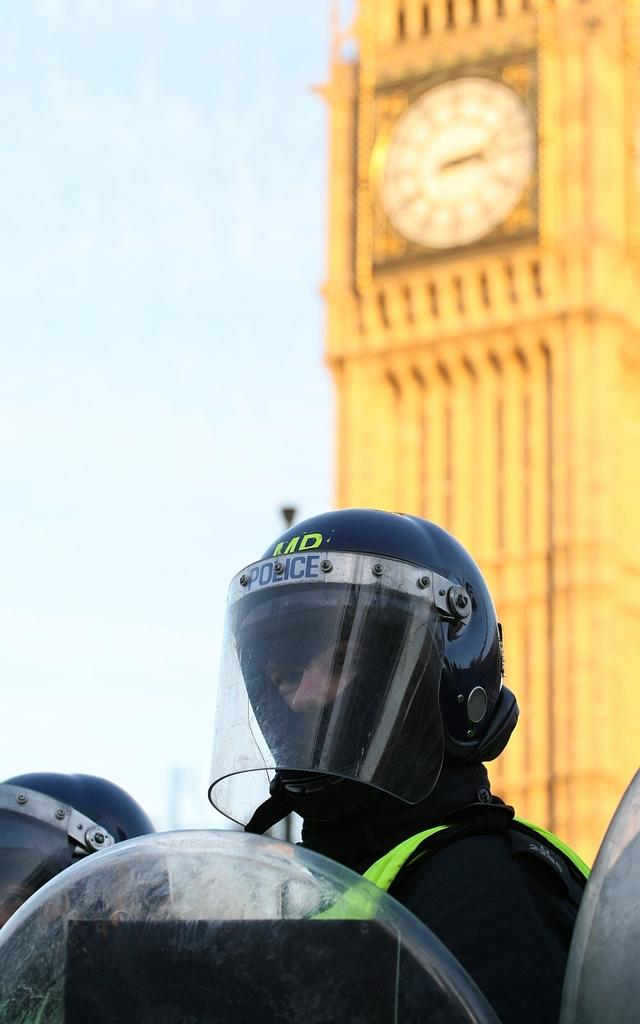Who or what is present in the image? There are people in the image. What are the people wearing on their heads? The people are wearing helmets. What can be seen in the background of the image? There is a clock tower and the sky visible in the background of the image. What type of books can be seen on the loaf of cream in the image? There are no books or loaf of cream present in the image. 